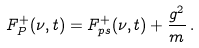Convert formula to latex. <formula><loc_0><loc_0><loc_500><loc_500>F ^ { + } _ { P } ( \nu , t ) = F ^ { + } _ { p s } ( \nu , t ) + \frac { g ^ { 2 } } { m } \, .</formula> 